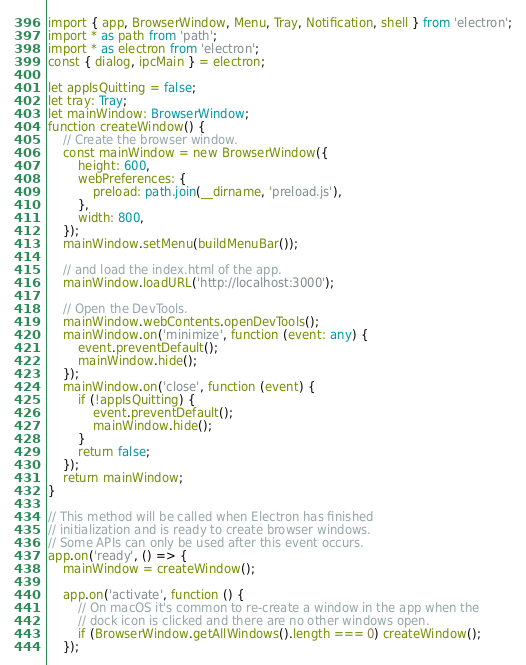Convert code to text. <code><loc_0><loc_0><loc_500><loc_500><_TypeScript_>import { app, BrowserWindow, Menu, Tray, Notification, shell } from 'electron';
import * as path from 'path';
import * as electron from 'electron';
const { dialog, ipcMain } = electron;

let appIsQuitting = false;
let tray: Tray;
let mainWindow: BrowserWindow;
function createWindow() {
    // Create the browser window.
    const mainWindow = new BrowserWindow({
        height: 600,
        webPreferences: {
            preload: path.join(__dirname, 'preload.js'),
        },
        width: 800,
    });
    mainWindow.setMenu(buildMenuBar());

    // and load the index.html of the app.
    mainWindow.loadURL('http://localhost:3000');

    // Open the DevTools.
    mainWindow.webContents.openDevTools();
    mainWindow.on('minimize', function (event: any) {
        event.preventDefault();
        mainWindow.hide();
    });
    mainWindow.on('close', function (event) {
        if (!appIsQuitting) {
            event.preventDefault();
            mainWindow.hide();
        }
        return false;
    });
    return mainWindow;
}

// This method will be called when Electron has finished
// initialization and is ready to create browser windows.
// Some APIs can only be used after this event occurs.
app.on('ready', () => {
    mainWindow = createWindow();

    app.on('activate', function () {
        // On macOS it's common to re-create a window in the app when the
        // dock icon is clicked and there are no other windows open.
        if (BrowserWindow.getAllWindows().length === 0) createWindow();
    });</code> 